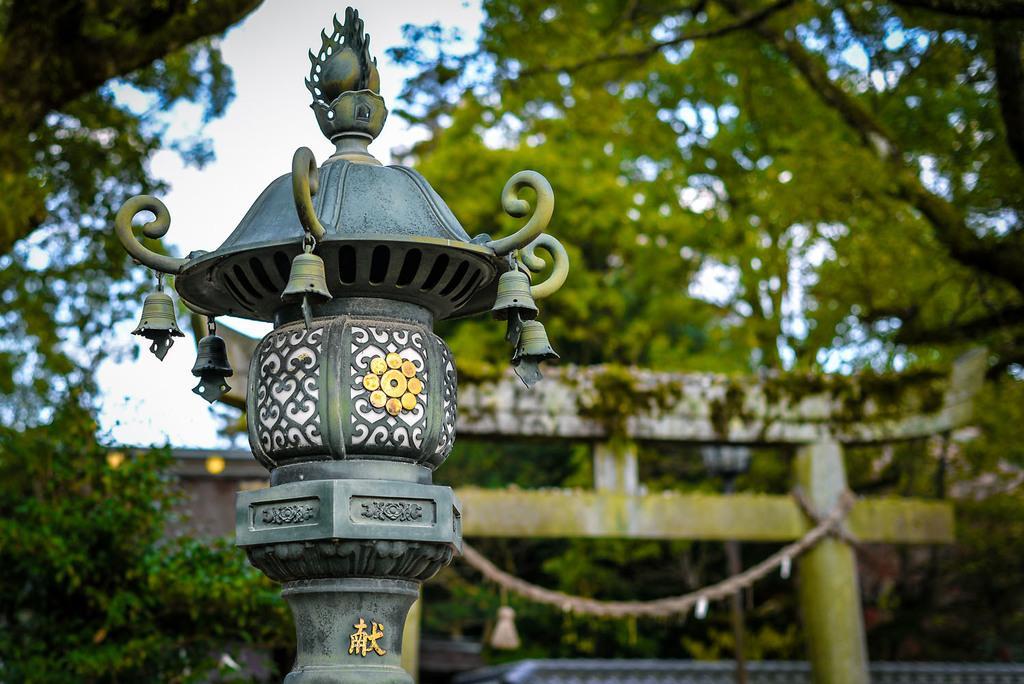Please provide a concise description of this image. In this image we can see there is a lamp post. In the background there are trees and sky. 